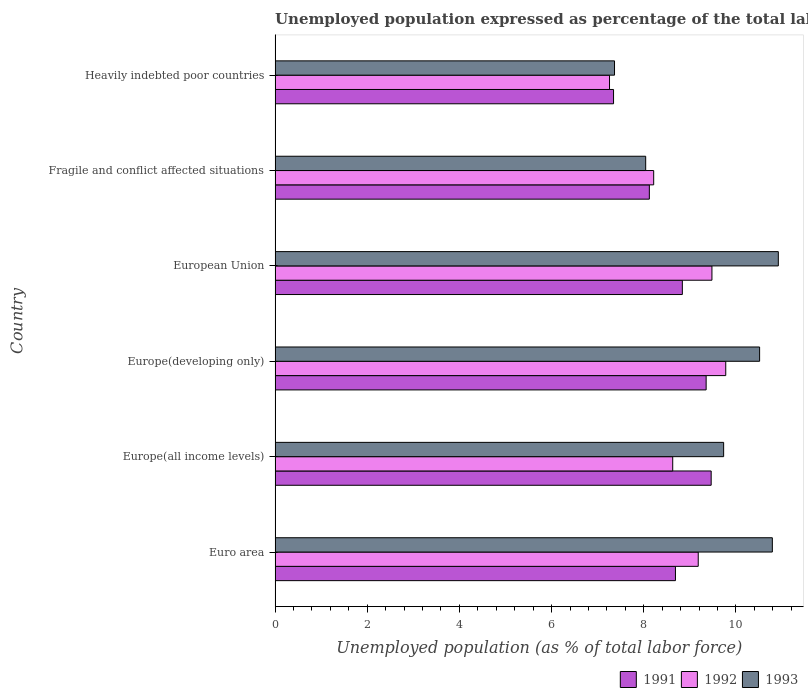How many different coloured bars are there?
Your answer should be compact. 3. Are the number of bars per tick equal to the number of legend labels?
Your answer should be very brief. Yes. What is the label of the 6th group of bars from the top?
Give a very brief answer. Euro area. What is the unemployment in in 1992 in Europe(all income levels)?
Your response must be concise. 8.63. Across all countries, what is the maximum unemployment in in 1991?
Give a very brief answer. 9.46. Across all countries, what is the minimum unemployment in in 1993?
Provide a succinct answer. 7.37. In which country was the unemployment in in 1992 maximum?
Keep it short and to the point. Europe(developing only). In which country was the unemployment in in 1993 minimum?
Offer a very short reply. Heavily indebted poor countries. What is the total unemployment in in 1992 in the graph?
Make the answer very short. 52.54. What is the difference between the unemployment in in 1991 in Europe(developing only) and that in European Union?
Provide a succinct answer. 0.52. What is the difference between the unemployment in in 1991 in Heavily indebted poor countries and the unemployment in in 1993 in Europe(developing only)?
Your answer should be very brief. -3.17. What is the average unemployment in in 1993 per country?
Offer a terse response. 9.56. What is the difference between the unemployment in in 1991 and unemployment in in 1992 in Europe(all income levels)?
Ensure brevity in your answer.  0.83. In how many countries, is the unemployment in in 1993 greater than 9.2 %?
Your answer should be compact. 4. What is the ratio of the unemployment in in 1992 in European Union to that in Heavily indebted poor countries?
Ensure brevity in your answer.  1.31. Is the unemployment in in 1993 in Europe(developing only) less than that in European Union?
Offer a very short reply. Yes. What is the difference between the highest and the second highest unemployment in in 1993?
Your answer should be very brief. 0.13. What is the difference between the highest and the lowest unemployment in in 1992?
Provide a succinct answer. 2.52. How many bars are there?
Keep it short and to the point. 18. How many countries are there in the graph?
Provide a succinct answer. 6. What is the difference between two consecutive major ticks on the X-axis?
Provide a short and direct response. 2. What is the title of the graph?
Offer a very short reply. Unemployed population expressed as percentage of the total labor force. What is the label or title of the X-axis?
Make the answer very short. Unemployed population (as % of total labor force). What is the label or title of the Y-axis?
Provide a short and direct response. Country. What is the Unemployed population (as % of total labor force) of 1991 in Euro area?
Your answer should be compact. 8.69. What is the Unemployed population (as % of total labor force) of 1992 in Euro area?
Provide a succinct answer. 9.18. What is the Unemployed population (as % of total labor force) of 1993 in Euro area?
Give a very brief answer. 10.79. What is the Unemployed population (as % of total labor force) of 1991 in Europe(all income levels)?
Give a very brief answer. 9.46. What is the Unemployed population (as % of total labor force) of 1992 in Europe(all income levels)?
Ensure brevity in your answer.  8.63. What is the Unemployed population (as % of total labor force) in 1993 in Europe(all income levels)?
Your response must be concise. 9.73. What is the Unemployed population (as % of total labor force) in 1991 in Europe(developing only)?
Offer a very short reply. 9.35. What is the Unemployed population (as % of total labor force) of 1992 in Europe(developing only)?
Your answer should be compact. 9.78. What is the Unemployed population (as % of total labor force) in 1993 in Europe(developing only)?
Make the answer very short. 10.51. What is the Unemployed population (as % of total labor force) of 1991 in European Union?
Make the answer very short. 8.84. What is the Unemployed population (as % of total labor force) of 1992 in European Union?
Your answer should be compact. 9.48. What is the Unemployed population (as % of total labor force) in 1993 in European Union?
Ensure brevity in your answer.  10.92. What is the Unemployed population (as % of total labor force) in 1991 in Fragile and conflict affected situations?
Give a very brief answer. 8.12. What is the Unemployed population (as % of total labor force) of 1992 in Fragile and conflict affected situations?
Your answer should be compact. 8.22. What is the Unemployed population (as % of total labor force) in 1993 in Fragile and conflict affected situations?
Your response must be concise. 8.04. What is the Unemployed population (as % of total labor force) of 1991 in Heavily indebted poor countries?
Your answer should be compact. 7.34. What is the Unemployed population (as % of total labor force) of 1992 in Heavily indebted poor countries?
Make the answer very short. 7.26. What is the Unemployed population (as % of total labor force) of 1993 in Heavily indebted poor countries?
Your response must be concise. 7.37. Across all countries, what is the maximum Unemployed population (as % of total labor force) of 1991?
Your response must be concise. 9.46. Across all countries, what is the maximum Unemployed population (as % of total labor force) in 1992?
Your answer should be very brief. 9.78. Across all countries, what is the maximum Unemployed population (as % of total labor force) in 1993?
Ensure brevity in your answer.  10.92. Across all countries, what is the minimum Unemployed population (as % of total labor force) in 1991?
Offer a terse response. 7.34. Across all countries, what is the minimum Unemployed population (as % of total labor force) in 1992?
Your response must be concise. 7.26. Across all countries, what is the minimum Unemployed population (as % of total labor force) of 1993?
Offer a terse response. 7.37. What is the total Unemployed population (as % of total labor force) in 1991 in the graph?
Offer a terse response. 51.81. What is the total Unemployed population (as % of total labor force) of 1992 in the graph?
Give a very brief answer. 52.54. What is the total Unemployed population (as % of total labor force) of 1993 in the graph?
Provide a succinct answer. 57.36. What is the difference between the Unemployed population (as % of total labor force) of 1991 in Euro area and that in Europe(all income levels)?
Your response must be concise. -0.77. What is the difference between the Unemployed population (as % of total labor force) in 1992 in Euro area and that in Europe(all income levels)?
Make the answer very short. 0.55. What is the difference between the Unemployed population (as % of total labor force) of 1993 in Euro area and that in Europe(all income levels)?
Offer a very short reply. 1.06. What is the difference between the Unemployed population (as % of total labor force) of 1991 in Euro area and that in Europe(developing only)?
Your answer should be very brief. -0.67. What is the difference between the Unemployed population (as % of total labor force) in 1992 in Euro area and that in Europe(developing only)?
Keep it short and to the point. -0.6. What is the difference between the Unemployed population (as % of total labor force) of 1993 in Euro area and that in Europe(developing only)?
Your answer should be compact. 0.28. What is the difference between the Unemployed population (as % of total labor force) in 1991 in Euro area and that in European Union?
Offer a very short reply. -0.15. What is the difference between the Unemployed population (as % of total labor force) in 1992 in Euro area and that in European Union?
Offer a very short reply. -0.3. What is the difference between the Unemployed population (as % of total labor force) in 1993 in Euro area and that in European Union?
Make the answer very short. -0.13. What is the difference between the Unemployed population (as % of total labor force) of 1991 in Euro area and that in Fragile and conflict affected situations?
Make the answer very short. 0.57. What is the difference between the Unemployed population (as % of total labor force) of 1992 in Euro area and that in Fragile and conflict affected situations?
Your answer should be compact. 0.97. What is the difference between the Unemployed population (as % of total labor force) in 1993 in Euro area and that in Fragile and conflict affected situations?
Ensure brevity in your answer.  2.75. What is the difference between the Unemployed population (as % of total labor force) of 1991 in Euro area and that in Heavily indebted poor countries?
Offer a terse response. 1.34. What is the difference between the Unemployed population (as % of total labor force) of 1992 in Euro area and that in Heavily indebted poor countries?
Provide a short and direct response. 1.93. What is the difference between the Unemployed population (as % of total labor force) in 1993 in Euro area and that in Heavily indebted poor countries?
Your answer should be very brief. 3.42. What is the difference between the Unemployed population (as % of total labor force) of 1991 in Europe(all income levels) and that in Europe(developing only)?
Keep it short and to the point. 0.11. What is the difference between the Unemployed population (as % of total labor force) in 1992 in Europe(all income levels) and that in Europe(developing only)?
Keep it short and to the point. -1.15. What is the difference between the Unemployed population (as % of total labor force) of 1993 in Europe(all income levels) and that in Europe(developing only)?
Your answer should be very brief. -0.78. What is the difference between the Unemployed population (as % of total labor force) in 1991 in Europe(all income levels) and that in European Union?
Ensure brevity in your answer.  0.63. What is the difference between the Unemployed population (as % of total labor force) of 1992 in Europe(all income levels) and that in European Union?
Keep it short and to the point. -0.85. What is the difference between the Unemployed population (as % of total labor force) in 1993 in Europe(all income levels) and that in European Union?
Your response must be concise. -1.19. What is the difference between the Unemployed population (as % of total labor force) in 1991 in Europe(all income levels) and that in Fragile and conflict affected situations?
Make the answer very short. 1.34. What is the difference between the Unemployed population (as % of total labor force) of 1992 in Europe(all income levels) and that in Fragile and conflict affected situations?
Ensure brevity in your answer.  0.41. What is the difference between the Unemployed population (as % of total labor force) of 1993 in Europe(all income levels) and that in Fragile and conflict affected situations?
Offer a terse response. 1.69. What is the difference between the Unemployed population (as % of total labor force) in 1991 in Europe(all income levels) and that in Heavily indebted poor countries?
Your answer should be compact. 2.12. What is the difference between the Unemployed population (as % of total labor force) of 1992 in Europe(all income levels) and that in Heavily indebted poor countries?
Ensure brevity in your answer.  1.37. What is the difference between the Unemployed population (as % of total labor force) in 1993 in Europe(all income levels) and that in Heavily indebted poor countries?
Your answer should be very brief. 2.37. What is the difference between the Unemployed population (as % of total labor force) of 1991 in Europe(developing only) and that in European Union?
Make the answer very short. 0.52. What is the difference between the Unemployed population (as % of total labor force) in 1992 in Europe(developing only) and that in European Union?
Your answer should be compact. 0.3. What is the difference between the Unemployed population (as % of total labor force) in 1993 in Europe(developing only) and that in European Union?
Offer a terse response. -0.41. What is the difference between the Unemployed population (as % of total labor force) in 1991 in Europe(developing only) and that in Fragile and conflict affected situations?
Your answer should be compact. 1.23. What is the difference between the Unemployed population (as % of total labor force) in 1992 in Europe(developing only) and that in Fragile and conflict affected situations?
Keep it short and to the point. 1.56. What is the difference between the Unemployed population (as % of total labor force) in 1993 in Europe(developing only) and that in Fragile and conflict affected situations?
Make the answer very short. 2.47. What is the difference between the Unemployed population (as % of total labor force) of 1991 in Europe(developing only) and that in Heavily indebted poor countries?
Offer a very short reply. 2.01. What is the difference between the Unemployed population (as % of total labor force) of 1992 in Europe(developing only) and that in Heavily indebted poor countries?
Your answer should be compact. 2.52. What is the difference between the Unemployed population (as % of total labor force) of 1993 in Europe(developing only) and that in Heavily indebted poor countries?
Offer a very short reply. 3.15. What is the difference between the Unemployed population (as % of total labor force) of 1991 in European Union and that in Fragile and conflict affected situations?
Provide a short and direct response. 0.72. What is the difference between the Unemployed population (as % of total labor force) of 1992 in European Union and that in Fragile and conflict affected situations?
Provide a short and direct response. 1.26. What is the difference between the Unemployed population (as % of total labor force) in 1993 in European Union and that in Fragile and conflict affected situations?
Ensure brevity in your answer.  2.88. What is the difference between the Unemployed population (as % of total labor force) of 1991 in European Union and that in Heavily indebted poor countries?
Your response must be concise. 1.49. What is the difference between the Unemployed population (as % of total labor force) of 1992 in European Union and that in Heavily indebted poor countries?
Your answer should be very brief. 2.22. What is the difference between the Unemployed population (as % of total labor force) of 1993 in European Union and that in Heavily indebted poor countries?
Make the answer very short. 3.55. What is the difference between the Unemployed population (as % of total labor force) of 1991 in Fragile and conflict affected situations and that in Heavily indebted poor countries?
Your response must be concise. 0.78. What is the difference between the Unemployed population (as % of total labor force) of 1992 in Fragile and conflict affected situations and that in Heavily indebted poor countries?
Your answer should be compact. 0.96. What is the difference between the Unemployed population (as % of total labor force) in 1993 in Fragile and conflict affected situations and that in Heavily indebted poor countries?
Provide a succinct answer. 0.68. What is the difference between the Unemployed population (as % of total labor force) of 1991 in Euro area and the Unemployed population (as % of total labor force) of 1992 in Europe(all income levels)?
Ensure brevity in your answer.  0.06. What is the difference between the Unemployed population (as % of total labor force) in 1991 in Euro area and the Unemployed population (as % of total labor force) in 1993 in Europe(all income levels)?
Offer a very short reply. -1.05. What is the difference between the Unemployed population (as % of total labor force) in 1992 in Euro area and the Unemployed population (as % of total labor force) in 1993 in Europe(all income levels)?
Keep it short and to the point. -0.55. What is the difference between the Unemployed population (as % of total labor force) of 1991 in Euro area and the Unemployed population (as % of total labor force) of 1992 in Europe(developing only)?
Provide a short and direct response. -1.09. What is the difference between the Unemployed population (as % of total labor force) of 1991 in Euro area and the Unemployed population (as % of total labor force) of 1993 in Europe(developing only)?
Your answer should be very brief. -1.83. What is the difference between the Unemployed population (as % of total labor force) of 1992 in Euro area and the Unemployed population (as % of total labor force) of 1993 in Europe(developing only)?
Your answer should be very brief. -1.33. What is the difference between the Unemployed population (as % of total labor force) of 1991 in Euro area and the Unemployed population (as % of total labor force) of 1992 in European Union?
Offer a very short reply. -0.79. What is the difference between the Unemployed population (as % of total labor force) of 1991 in Euro area and the Unemployed population (as % of total labor force) of 1993 in European Union?
Keep it short and to the point. -2.23. What is the difference between the Unemployed population (as % of total labor force) of 1992 in Euro area and the Unemployed population (as % of total labor force) of 1993 in European Union?
Offer a very short reply. -1.74. What is the difference between the Unemployed population (as % of total labor force) in 1991 in Euro area and the Unemployed population (as % of total labor force) in 1992 in Fragile and conflict affected situations?
Ensure brevity in your answer.  0.47. What is the difference between the Unemployed population (as % of total labor force) of 1991 in Euro area and the Unemployed population (as % of total labor force) of 1993 in Fragile and conflict affected situations?
Your answer should be compact. 0.65. What is the difference between the Unemployed population (as % of total labor force) in 1992 in Euro area and the Unemployed population (as % of total labor force) in 1993 in Fragile and conflict affected situations?
Offer a terse response. 1.14. What is the difference between the Unemployed population (as % of total labor force) of 1991 in Euro area and the Unemployed population (as % of total labor force) of 1992 in Heavily indebted poor countries?
Ensure brevity in your answer.  1.43. What is the difference between the Unemployed population (as % of total labor force) of 1991 in Euro area and the Unemployed population (as % of total labor force) of 1993 in Heavily indebted poor countries?
Offer a very short reply. 1.32. What is the difference between the Unemployed population (as % of total labor force) in 1992 in Euro area and the Unemployed population (as % of total labor force) in 1993 in Heavily indebted poor countries?
Your response must be concise. 1.82. What is the difference between the Unemployed population (as % of total labor force) in 1991 in Europe(all income levels) and the Unemployed population (as % of total labor force) in 1992 in Europe(developing only)?
Offer a terse response. -0.32. What is the difference between the Unemployed population (as % of total labor force) of 1991 in Europe(all income levels) and the Unemployed population (as % of total labor force) of 1993 in Europe(developing only)?
Offer a terse response. -1.05. What is the difference between the Unemployed population (as % of total labor force) of 1992 in Europe(all income levels) and the Unemployed population (as % of total labor force) of 1993 in Europe(developing only)?
Your response must be concise. -1.89. What is the difference between the Unemployed population (as % of total labor force) in 1991 in Europe(all income levels) and the Unemployed population (as % of total labor force) in 1992 in European Union?
Make the answer very short. -0.02. What is the difference between the Unemployed population (as % of total labor force) of 1991 in Europe(all income levels) and the Unemployed population (as % of total labor force) of 1993 in European Union?
Provide a succinct answer. -1.46. What is the difference between the Unemployed population (as % of total labor force) in 1992 in Europe(all income levels) and the Unemployed population (as % of total labor force) in 1993 in European Union?
Ensure brevity in your answer.  -2.29. What is the difference between the Unemployed population (as % of total labor force) in 1991 in Europe(all income levels) and the Unemployed population (as % of total labor force) in 1992 in Fragile and conflict affected situations?
Keep it short and to the point. 1.25. What is the difference between the Unemployed population (as % of total labor force) in 1991 in Europe(all income levels) and the Unemployed population (as % of total labor force) in 1993 in Fragile and conflict affected situations?
Your answer should be very brief. 1.42. What is the difference between the Unemployed population (as % of total labor force) of 1992 in Europe(all income levels) and the Unemployed population (as % of total labor force) of 1993 in Fragile and conflict affected situations?
Offer a very short reply. 0.59. What is the difference between the Unemployed population (as % of total labor force) in 1991 in Europe(all income levels) and the Unemployed population (as % of total labor force) in 1992 in Heavily indebted poor countries?
Offer a terse response. 2.21. What is the difference between the Unemployed population (as % of total labor force) of 1991 in Europe(all income levels) and the Unemployed population (as % of total labor force) of 1993 in Heavily indebted poor countries?
Provide a succinct answer. 2.1. What is the difference between the Unemployed population (as % of total labor force) of 1992 in Europe(all income levels) and the Unemployed population (as % of total labor force) of 1993 in Heavily indebted poor countries?
Keep it short and to the point. 1.26. What is the difference between the Unemployed population (as % of total labor force) of 1991 in Europe(developing only) and the Unemployed population (as % of total labor force) of 1992 in European Union?
Keep it short and to the point. -0.13. What is the difference between the Unemployed population (as % of total labor force) of 1991 in Europe(developing only) and the Unemployed population (as % of total labor force) of 1993 in European Union?
Provide a short and direct response. -1.57. What is the difference between the Unemployed population (as % of total labor force) of 1992 in Europe(developing only) and the Unemployed population (as % of total labor force) of 1993 in European Union?
Your answer should be very brief. -1.14. What is the difference between the Unemployed population (as % of total labor force) of 1991 in Europe(developing only) and the Unemployed population (as % of total labor force) of 1992 in Fragile and conflict affected situations?
Your response must be concise. 1.14. What is the difference between the Unemployed population (as % of total labor force) of 1991 in Europe(developing only) and the Unemployed population (as % of total labor force) of 1993 in Fragile and conflict affected situations?
Make the answer very short. 1.31. What is the difference between the Unemployed population (as % of total labor force) in 1992 in Europe(developing only) and the Unemployed population (as % of total labor force) in 1993 in Fragile and conflict affected situations?
Provide a succinct answer. 1.74. What is the difference between the Unemployed population (as % of total labor force) in 1991 in Europe(developing only) and the Unemployed population (as % of total labor force) in 1992 in Heavily indebted poor countries?
Offer a very short reply. 2.1. What is the difference between the Unemployed population (as % of total labor force) in 1991 in Europe(developing only) and the Unemployed population (as % of total labor force) in 1993 in Heavily indebted poor countries?
Keep it short and to the point. 1.99. What is the difference between the Unemployed population (as % of total labor force) of 1992 in Europe(developing only) and the Unemployed population (as % of total labor force) of 1993 in Heavily indebted poor countries?
Offer a terse response. 2.41. What is the difference between the Unemployed population (as % of total labor force) of 1991 in European Union and the Unemployed population (as % of total labor force) of 1992 in Fragile and conflict affected situations?
Ensure brevity in your answer.  0.62. What is the difference between the Unemployed population (as % of total labor force) of 1991 in European Union and the Unemployed population (as % of total labor force) of 1993 in Fragile and conflict affected situations?
Keep it short and to the point. 0.8. What is the difference between the Unemployed population (as % of total labor force) in 1992 in European Union and the Unemployed population (as % of total labor force) in 1993 in Fragile and conflict affected situations?
Make the answer very short. 1.44. What is the difference between the Unemployed population (as % of total labor force) in 1991 in European Union and the Unemployed population (as % of total labor force) in 1992 in Heavily indebted poor countries?
Offer a terse response. 1.58. What is the difference between the Unemployed population (as % of total labor force) of 1991 in European Union and the Unemployed population (as % of total labor force) of 1993 in Heavily indebted poor countries?
Keep it short and to the point. 1.47. What is the difference between the Unemployed population (as % of total labor force) of 1992 in European Union and the Unemployed population (as % of total labor force) of 1993 in Heavily indebted poor countries?
Your answer should be compact. 2.11. What is the difference between the Unemployed population (as % of total labor force) in 1991 in Fragile and conflict affected situations and the Unemployed population (as % of total labor force) in 1992 in Heavily indebted poor countries?
Offer a terse response. 0.86. What is the difference between the Unemployed population (as % of total labor force) of 1991 in Fragile and conflict affected situations and the Unemployed population (as % of total labor force) of 1993 in Heavily indebted poor countries?
Provide a succinct answer. 0.76. What is the difference between the Unemployed population (as % of total labor force) in 1992 in Fragile and conflict affected situations and the Unemployed population (as % of total labor force) in 1993 in Heavily indebted poor countries?
Ensure brevity in your answer.  0.85. What is the average Unemployed population (as % of total labor force) in 1991 per country?
Give a very brief answer. 8.63. What is the average Unemployed population (as % of total labor force) of 1992 per country?
Offer a terse response. 8.76. What is the average Unemployed population (as % of total labor force) of 1993 per country?
Offer a terse response. 9.56. What is the difference between the Unemployed population (as % of total labor force) in 1991 and Unemployed population (as % of total labor force) in 1992 in Euro area?
Keep it short and to the point. -0.49. What is the difference between the Unemployed population (as % of total labor force) in 1991 and Unemployed population (as % of total labor force) in 1993 in Euro area?
Keep it short and to the point. -2.1. What is the difference between the Unemployed population (as % of total labor force) of 1992 and Unemployed population (as % of total labor force) of 1993 in Euro area?
Ensure brevity in your answer.  -1.61. What is the difference between the Unemployed population (as % of total labor force) of 1991 and Unemployed population (as % of total labor force) of 1992 in Europe(all income levels)?
Your answer should be compact. 0.83. What is the difference between the Unemployed population (as % of total labor force) in 1991 and Unemployed population (as % of total labor force) in 1993 in Europe(all income levels)?
Make the answer very short. -0.27. What is the difference between the Unemployed population (as % of total labor force) of 1992 and Unemployed population (as % of total labor force) of 1993 in Europe(all income levels)?
Your answer should be very brief. -1.1. What is the difference between the Unemployed population (as % of total labor force) of 1991 and Unemployed population (as % of total labor force) of 1992 in Europe(developing only)?
Offer a terse response. -0.43. What is the difference between the Unemployed population (as % of total labor force) of 1991 and Unemployed population (as % of total labor force) of 1993 in Europe(developing only)?
Provide a succinct answer. -1.16. What is the difference between the Unemployed population (as % of total labor force) in 1992 and Unemployed population (as % of total labor force) in 1993 in Europe(developing only)?
Your answer should be compact. -0.73. What is the difference between the Unemployed population (as % of total labor force) of 1991 and Unemployed population (as % of total labor force) of 1992 in European Union?
Ensure brevity in your answer.  -0.64. What is the difference between the Unemployed population (as % of total labor force) of 1991 and Unemployed population (as % of total labor force) of 1993 in European Union?
Your response must be concise. -2.08. What is the difference between the Unemployed population (as % of total labor force) in 1992 and Unemployed population (as % of total labor force) in 1993 in European Union?
Give a very brief answer. -1.44. What is the difference between the Unemployed population (as % of total labor force) of 1991 and Unemployed population (as % of total labor force) of 1992 in Fragile and conflict affected situations?
Your answer should be very brief. -0.09. What is the difference between the Unemployed population (as % of total labor force) in 1991 and Unemployed population (as % of total labor force) in 1993 in Fragile and conflict affected situations?
Your answer should be very brief. 0.08. What is the difference between the Unemployed population (as % of total labor force) of 1992 and Unemployed population (as % of total labor force) of 1993 in Fragile and conflict affected situations?
Provide a short and direct response. 0.17. What is the difference between the Unemployed population (as % of total labor force) of 1991 and Unemployed population (as % of total labor force) of 1992 in Heavily indebted poor countries?
Offer a very short reply. 0.09. What is the difference between the Unemployed population (as % of total labor force) in 1991 and Unemployed population (as % of total labor force) in 1993 in Heavily indebted poor countries?
Your answer should be very brief. -0.02. What is the difference between the Unemployed population (as % of total labor force) in 1992 and Unemployed population (as % of total labor force) in 1993 in Heavily indebted poor countries?
Give a very brief answer. -0.11. What is the ratio of the Unemployed population (as % of total labor force) of 1991 in Euro area to that in Europe(all income levels)?
Provide a succinct answer. 0.92. What is the ratio of the Unemployed population (as % of total labor force) of 1992 in Euro area to that in Europe(all income levels)?
Ensure brevity in your answer.  1.06. What is the ratio of the Unemployed population (as % of total labor force) of 1993 in Euro area to that in Europe(all income levels)?
Your answer should be very brief. 1.11. What is the ratio of the Unemployed population (as % of total labor force) in 1991 in Euro area to that in Europe(developing only)?
Offer a very short reply. 0.93. What is the ratio of the Unemployed population (as % of total labor force) in 1992 in Euro area to that in Europe(developing only)?
Give a very brief answer. 0.94. What is the ratio of the Unemployed population (as % of total labor force) in 1993 in Euro area to that in Europe(developing only)?
Provide a short and direct response. 1.03. What is the ratio of the Unemployed population (as % of total labor force) of 1991 in Euro area to that in European Union?
Your answer should be very brief. 0.98. What is the ratio of the Unemployed population (as % of total labor force) in 1992 in Euro area to that in European Union?
Keep it short and to the point. 0.97. What is the ratio of the Unemployed population (as % of total labor force) in 1993 in Euro area to that in European Union?
Offer a very short reply. 0.99. What is the ratio of the Unemployed population (as % of total labor force) in 1991 in Euro area to that in Fragile and conflict affected situations?
Give a very brief answer. 1.07. What is the ratio of the Unemployed population (as % of total labor force) of 1992 in Euro area to that in Fragile and conflict affected situations?
Ensure brevity in your answer.  1.12. What is the ratio of the Unemployed population (as % of total labor force) of 1993 in Euro area to that in Fragile and conflict affected situations?
Provide a succinct answer. 1.34. What is the ratio of the Unemployed population (as % of total labor force) in 1991 in Euro area to that in Heavily indebted poor countries?
Keep it short and to the point. 1.18. What is the ratio of the Unemployed population (as % of total labor force) in 1992 in Euro area to that in Heavily indebted poor countries?
Offer a terse response. 1.27. What is the ratio of the Unemployed population (as % of total labor force) in 1993 in Euro area to that in Heavily indebted poor countries?
Offer a terse response. 1.47. What is the ratio of the Unemployed population (as % of total labor force) of 1991 in Europe(all income levels) to that in Europe(developing only)?
Give a very brief answer. 1.01. What is the ratio of the Unemployed population (as % of total labor force) in 1992 in Europe(all income levels) to that in Europe(developing only)?
Your response must be concise. 0.88. What is the ratio of the Unemployed population (as % of total labor force) of 1993 in Europe(all income levels) to that in Europe(developing only)?
Your response must be concise. 0.93. What is the ratio of the Unemployed population (as % of total labor force) of 1991 in Europe(all income levels) to that in European Union?
Your answer should be very brief. 1.07. What is the ratio of the Unemployed population (as % of total labor force) of 1992 in Europe(all income levels) to that in European Union?
Provide a succinct answer. 0.91. What is the ratio of the Unemployed population (as % of total labor force) of 1993 in Europe(all income levels) to that in European Union?
Your answer should be very brief. 0.89. What is the ratio of the Unemployed population (as % of total labor force) in 1991 in Europe(all income levels) to that in Fragile and conflict affected situations?
Ensure brevity in your answer.  1.17. What is the ratio of the Unemployed population (as % of total labor force) of 1992 in Europe(all income levels) to that in Fragile and conflict affected situations?
Give a very brief answer. 1.05. What is the ratio of the Unemployed population (as % of total labor force) of 1993 in Europe(all income levels) to that in Fragile and conflict affected situations?
Keep it short and to the point. 1.21. What is the ratio of the Unemployed population (as % of total labor force) of 1991 in Europe(all income levels) to that in Heavily indebted poor countries?
Your answer should be very brief. 1.29. What is the ratio of the Unemployed population (as % of total labor force) of 1992 in Europe(all income levels) to that in Heavily indebted poor countries?
Your response must be concise. 1.19. What is the ratio of the Unemployed population (as % of total labor force) of 1993 in Europe(all income levels) to that in Heavily indebted poor countries?
Keep it short and to the point. 1.32. What is the ratio of the Unemployed population (as % of total labor force) of 1991 in Europe(developing only) to that in European Union?
Provide a succinct answer. 1.06. What is the ratio of the Unemployed population (as % of total labor force) of 1992 in Europe(developing only) to that in European Union?
Make the answer very short. 1.03. What is the ratio of the Unemployed population (as % of total labor force) in 1993 in Europe(developing only) to that in European Union?
Ensure brevity in your answer.  0.96. What is the ratio of the Unemployed population (as % of total labor force) of 1991 in Europe(developing only) to that in Fragile and conflict affected situations?
Offer a very short reply. 1.15. What is the ratio of the Unemployed population (as % of total labor force) of 1992 in Europe(developing only) to that in Fragile and conflict affected situations?
Offer a very short reply. 1.19. What is the ratio of the Unemployed population (as % of total labor force) of 1993 in Europe(developing only) to that in Fragile and conflict affected situations?
Keep it short and to the point. 1.31. What is the ratio of the Unemployed population (as % of total labor force) in 1991 in Europe(developing only) to that in Heavily indebted poor countries?
Ensure brevity in your answer.  1.27. What is the ratio of the Unemployed population (as % of total labor force) of 1992 in Europe(developing only) to that in Heavily indebted poor countries?
Provide a short and direct response. 1.35. What is the ratio of the Unemployed population (as % of total labor force) in 1993 in Europe(developing only) to that in Heavily indebted poor countries?
Ensure brevity in your answer.  1.43. What is the ratio of the Unemployed population (as % of total labor force) of 1991 in European Union to that in Fragile and conflict affected situations?
Provide a succinct answer. 1.09. What is the ratio of the Unemployed population (as % of total labor force) of 1992 in European Union to that in Fragile and conflict affected situations?
Provide a short and direct response. 1.15. What is the ratio of the Unemployed population (as % of total labor force) of 1993 in European Union to that in Fragile and conflict affected situations?
Provide a succinct answer. 1.36. What is the ratio of the Unemployed population (as % of total labor force) in 1991 in European Union to that in Heavily indebted poor countries?
Provide a succinct answer. 1.2. What is the ratio of the Unemployed population (as % of total labor force) in 1992 in European Union to that in Heavily indebted poor countries?
Your answer should be compact. 1.31. What is the ratio of the Unemployed population (as % of total labor force) in 1993 in European Union to that in Heavily indebted poor countries?
Ensure brevity in your answer.  1.48. What is the ratio of the Unemployed population (as % of total labor force) of 1991 in Fragile and conflict affected situations to that in Heavily indebted poor countries?
Provide a succinct answer. 1.11. What is the ratio of the Unemployed population (as % of total labor force) of 1992 in Fragile and conflict affected situations to that in Heavily indebted poor countries?
Ensure brevity in your answer.  1.13. What is the ratio of the Unemployed population (as % of total labor force) of 1993 in Fragile and conflict affected situations to that in Heavily indebted poor countries?
Your answer should be very brief. 1.09. What is the difference between the highest and the second highest Unemployed population (as % of total labor force) of 1991?
Your answer should be compact. 0.11. What is the difference between the highest and the second highest Unemployed population (as % of total labor force) in 1992?
Provide a succinct answer. 0.3. What is the difference between the highest and the second highest Unemployed population (as % of total labor force) in 1993?
Ensure brevity in your answer.  0.13. What is the difference between the highest and the lowest Unemployed population (as % of total labor force) of 1991?
Make the answer very short. 2.12. What is the difference between the highest and the lowest Unemployed population (as % of total labor force) in 1992?
Give a very brief answer. 2.52. What is the difference between the highest and the lowest Unemployed population (as % of total labor force) of 1993?
Provide a succinct answer. 3.55. 